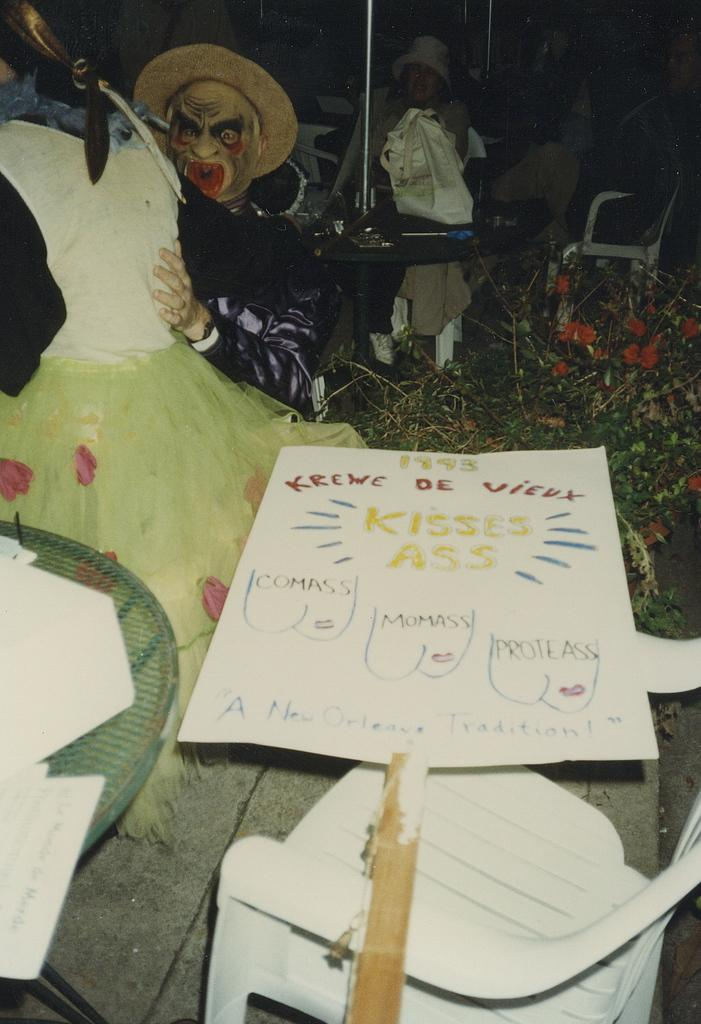<image>
Summarize the visual content of the image. A homemade sign that reads 1995 Krewe de Vieux Kisses Ass next to some costumed people. 